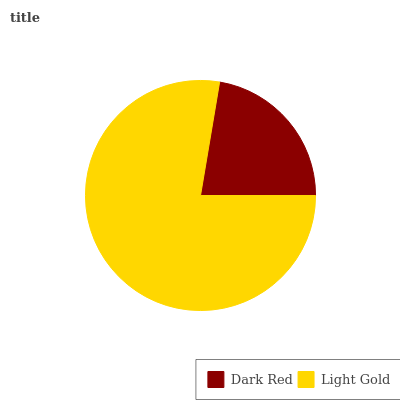Is Dark Red the minimum?
Answer yes or no. Yes. Is Light Gold the maximum?
Answer yes or no. Yes. Is Light Gold the minimum?
Answer yes or no. No. Is Light Gold greater than Dark Red?
Answer yes or no. Yes. Is Dark Red less than Light Gold?
Answer yes or no. Yes. Is Dark Red greater than Light Gold?
Answer yes or no. No. Is Light Gold less than Dark Red?
Answer yes or no. No. Is Light Gold the high median?
Answer yes or no. Yes. Is Dark Red the low median?
Answer yes or no. Yes. Is Dark Red the high median?
Answer yes or no. No. Is Light Gold the low median?
Answer yes or no. No. 